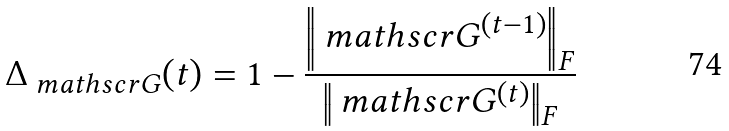<formula> <loc_0><loc_0><loc_500><loc_500>\Delta _ { \ m a t h s c r { G } } ( t ) = 1 - \frac { \left \| \ m a t h s c r { G } ^ { ( t - 1 ) } \right \| _ { F } } { \left \| \ m a t h s c r { G } ^ { ( t ) } \right \| _ { F } }</formula> 